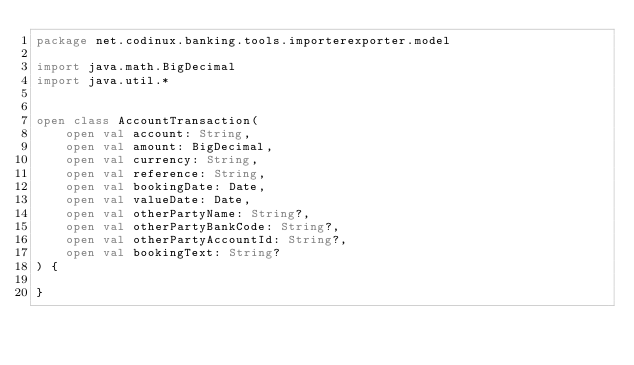<code> <loc_0><loc_0><loc_500><loc_500><_Kotlin_>package net.codinux.banking.tools.importerexporter.model

import java.math.BigDecimal
import java.util.*


open class AccountTransaction(
    open val account: String,
    open val amount: BigDecimal,
    open val currency: String,
    open val reference: String,
    open val bookingDate: Date,
    open val valueDate: Date,
    open val otherPartyName: String?,
    open val otherPartyBankCode: String?,
    open val otherPartyAccountId: String?,
    open val bookingText: String?
) {

}</code> 